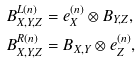<formula> <loc_0><loc_0><loc_500><loc_500>B _ { X , Y , Z } ^ { L \left ( n \right ) } & = e _ { X } ^ { \left ( n \right ) } \otimes B _ { Y , Z } , \\ B _ { X , Y , Z } ^ { R \left ( n \right ) } & = B _ { X , Y } \otimes e _ { Z } ^ { \left ( n \right ) } ,</formula> 